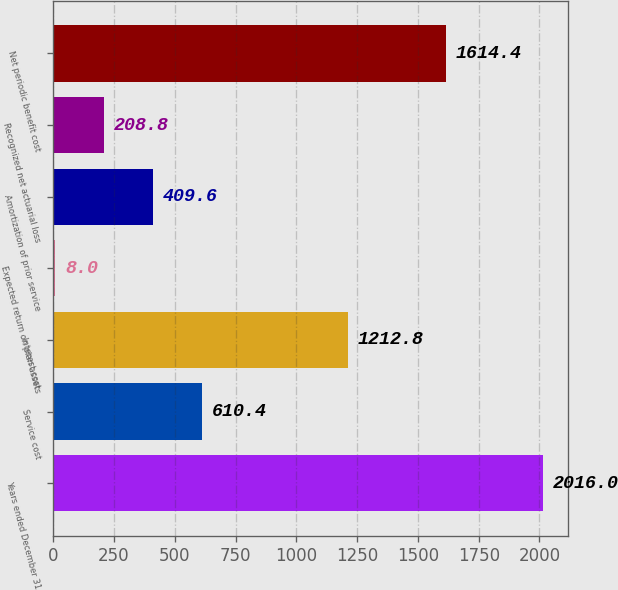<chart> <loc_0><loc_0><loc_500><loc_500><bar_chart><fcel>Years ended December 31<fcel>Service cost<fcel>Interest cost<fcel>Expected return on plan assets<fcel>Amortization of prior service<fcel>Recognized net actuarial loss<fcel>Net periodic benefit cost<nl><fcel>2016<fcel>610.4<fcel>1212.8<fcel>8<fcel>409.6<fcel>208.8<fcel>1614.4<nl></chart> 